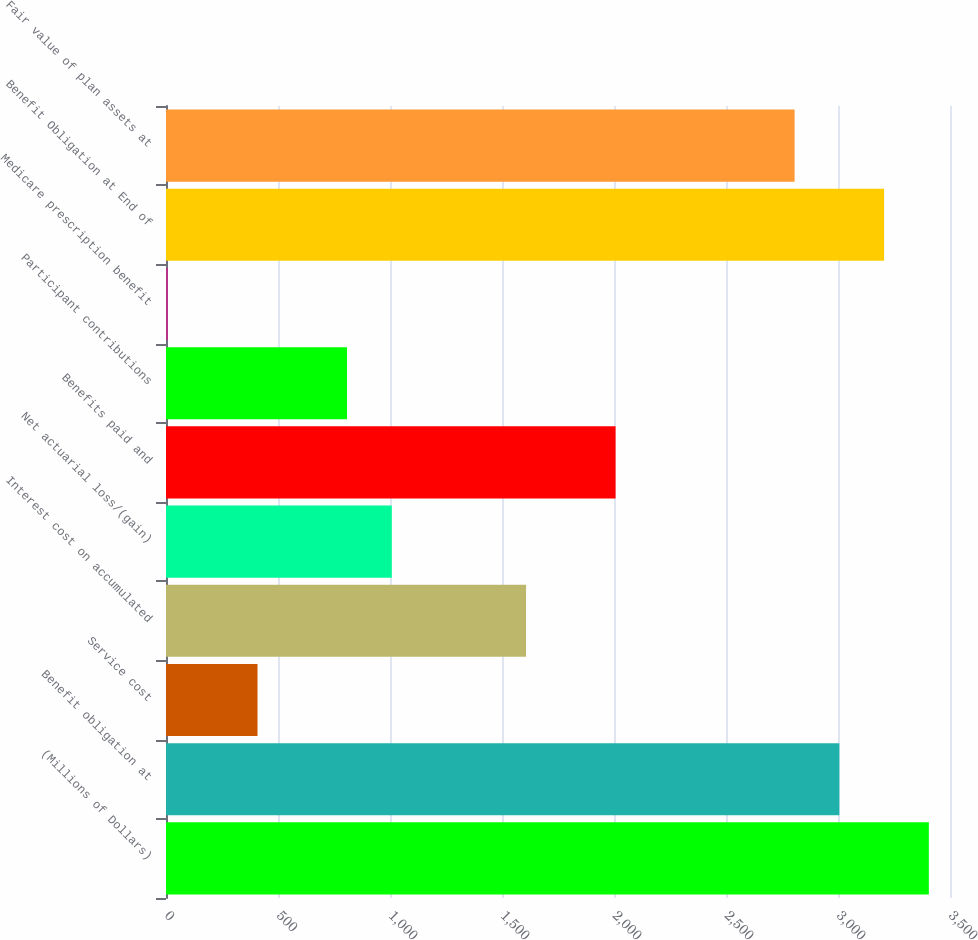Convert chart. <chart><loc_0><loc_0><loc_500><loc_500><bar_chart><fcel>(Millions of Dollars)<fcel>Benefit obligation at<fcel>Service cost<fcel>Interest cost on accumulated<fcel>Net actuarial loss/(gain)<fcel>Benefits paid and<fcel>Participant contributions<fcel>Medicare prescription benefit<fcel>Benefit Obligation at End of<fcel>Fair value of plan assets at<nl><fcel>3405.6<fcel>3006<fcel>408.6<fcel>1607.4<fcel>1008<fcel>2007<fcel>808.2<fcel>9<fcel>3205.8<fcel>2806.2<nl></chart> 